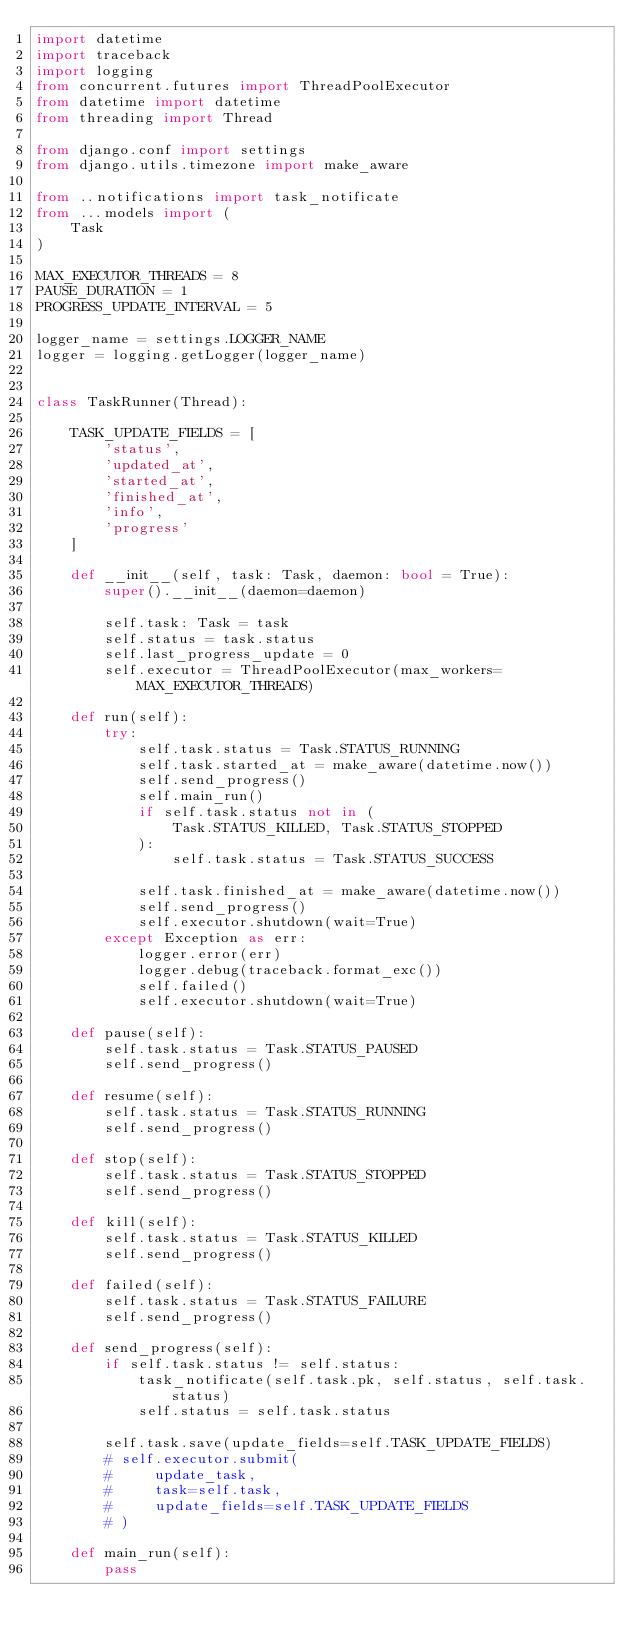<code> <loc_0><loc_0><loc_500><loc_500><_Python_>import datetime
import traceback
import logging
from concurrent.futures import ThreadPoolExecutor
from datetime import datetime
from threading import Thread

from django.conf import settings
from django.utils.timezone import make_aware

from ..notifications import task_notificate
from ...models import (
    Task
)

MAX_EXECUTOR_THREADS = 8
PAUSE_DURATION = 1
PROGRESS_UPDATE_INTERVAL = 5

logger_name = settings.LOGGER_NAME
logger = logging.getLogger(logger_name)


class TaskRunner(Thread):

    TASK_UPDATE_FIELDS = [
        'status',
        'updated_at',
        'started_at',
        'finished_at',
        'info',
        'progress'
    ]

    def __init__(self, task: Task, daemon: bool = True):
        super().__init__(daemon=daemon)

        self.task: Task = task
        self.status = task.status
        self.last_progress_update = 0
        self.executor = ThreadPoolExecutor(max_workers=MAX_EXECUTOR_THREADS)

    def run(self):
        try:
            self.task.status = Task.STATUS_RUNNING
            self.task.started_at = make_aware(datetime.now())
            self.send_progress()
            self.main_run()
            if self.task.status not in (
                Task.STATUS_KILLED, Task.STATUS_STOPPED
            ):
                self.task.status = Task.STATUS_SUCCESS

            self.task.finished_at = make_aware(datetime.now())
            self.send_progress()
            self.executor.shutdown(wait=True)
        except Exception as err:
            logger.error(err)
            logger.debug(traceback.format_exc())
            self.failed()
            self.executor.shutdown(wait=True)

    def pause(self):
        self.task.status = Task.STATUS_PAUSED
        self.send_progress()

    def resume(self):
        self.task.status = Task.STATUS_RUNNING
        self.send_progress()

    def stop(self):
        self.task.status = Task.STATUS_STOPPED
        self.send_progress()

    def kill(self):
        self.task.status = Task.STATUS_KILLED
        self.send_progress()

    def failed(self):
        self.task.status = Task.STATUS_FAILURE
        self.send_progress()

    def send_progress(self):
        if self.task.status != self.status:
            task_notificate(self.task.pk, self.status, self.task.status)
            self.status = self.task.status

        self.task.save(update_fields=self.TASK_UPDATE_FIELDS)
        # self.executor.submit(
        #     update_task,
        #     task=self.task,
        #     update_fields=self.TASK_UPDATE_FIELDS
        # )

    def main_run(self):
        pass
</code> 